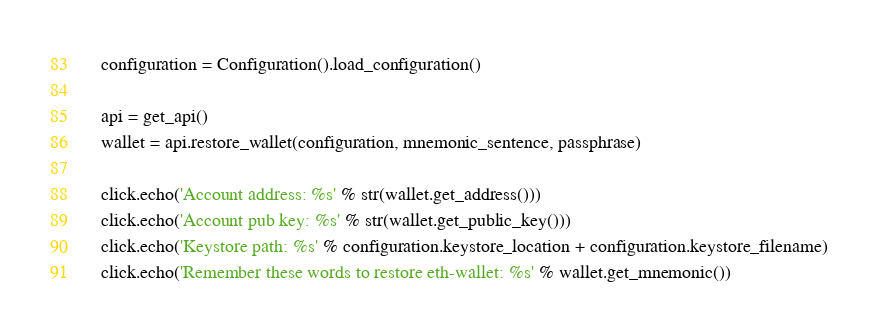Convert code to text. <code><loc_0><loc_0><loc_500><loc_500><_Python_>    configuration = Configuration().load_configuration()

    api = get_api()
    wallet = api.restore_wallet(configuration, mnemonic_sentence, passphrase)

    click.echo('Account address: %s' % str(wallet.get_address()))
    click.echo('Account pub key: %s' % str(wallet.get_public_key()))
    click.echo('Keystore path: %s' % configuration.keystore_location + configuration.keystore_filename)
    click.echo('Remember these words to restore eth-wallet: %s' % wallet.get_mnemonic())




</code> 